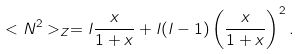<formula> <loc_0><loc_0><loc_500><loc_500>< N ^ { 2 } > _ { Z } = l \frac { x } { 1 + x } + l ( l - 1 ) \left ( \frac { x } { 1 + x } \right ) ^ { 2 } .</formula> 